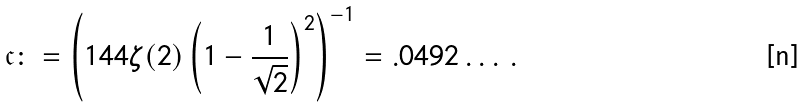<formula> <loc_0><loc_0><loc_500><loc_500>\mathfrak { c } & \colon = \left ( 1 4 4 \zeta ( 2 ) \left ( 1 - \frac { 1 } { \sqrt { 2 } } \right ) ^ { 2 } \right ) ^ { - 1 } = . 0 4 9 2 \dots \, .</formula> 